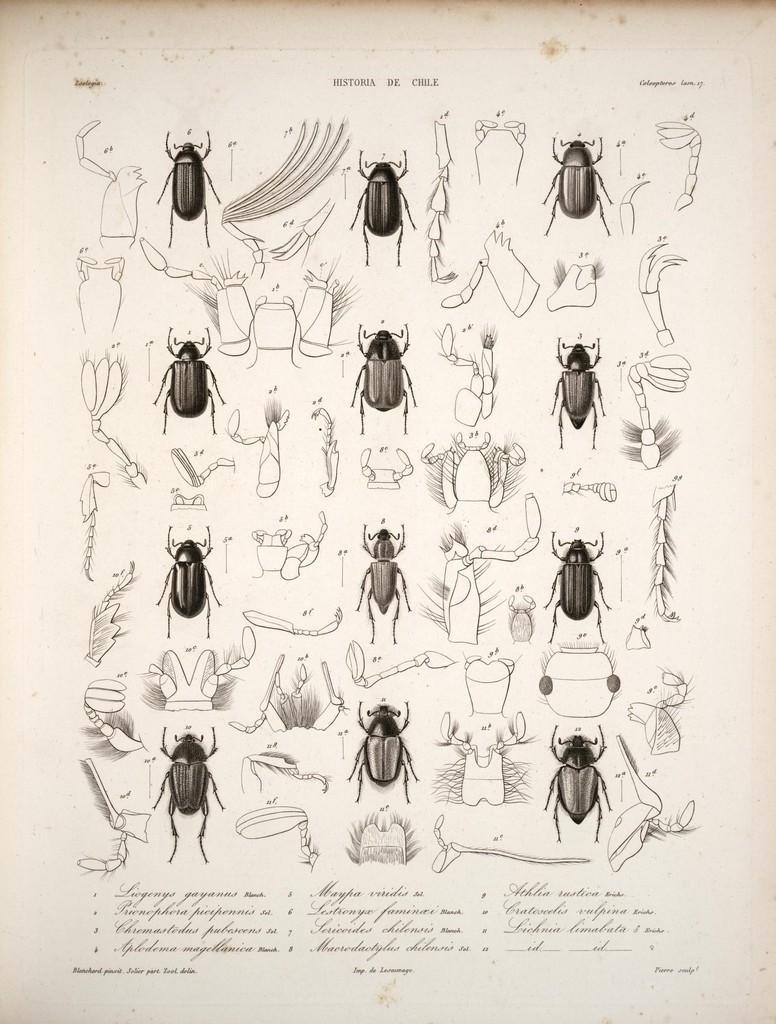Please provide a concise description of this image. In this image there are some pictures of an insects as we can see in middle of this image and there is some text written at bottom of this image. 